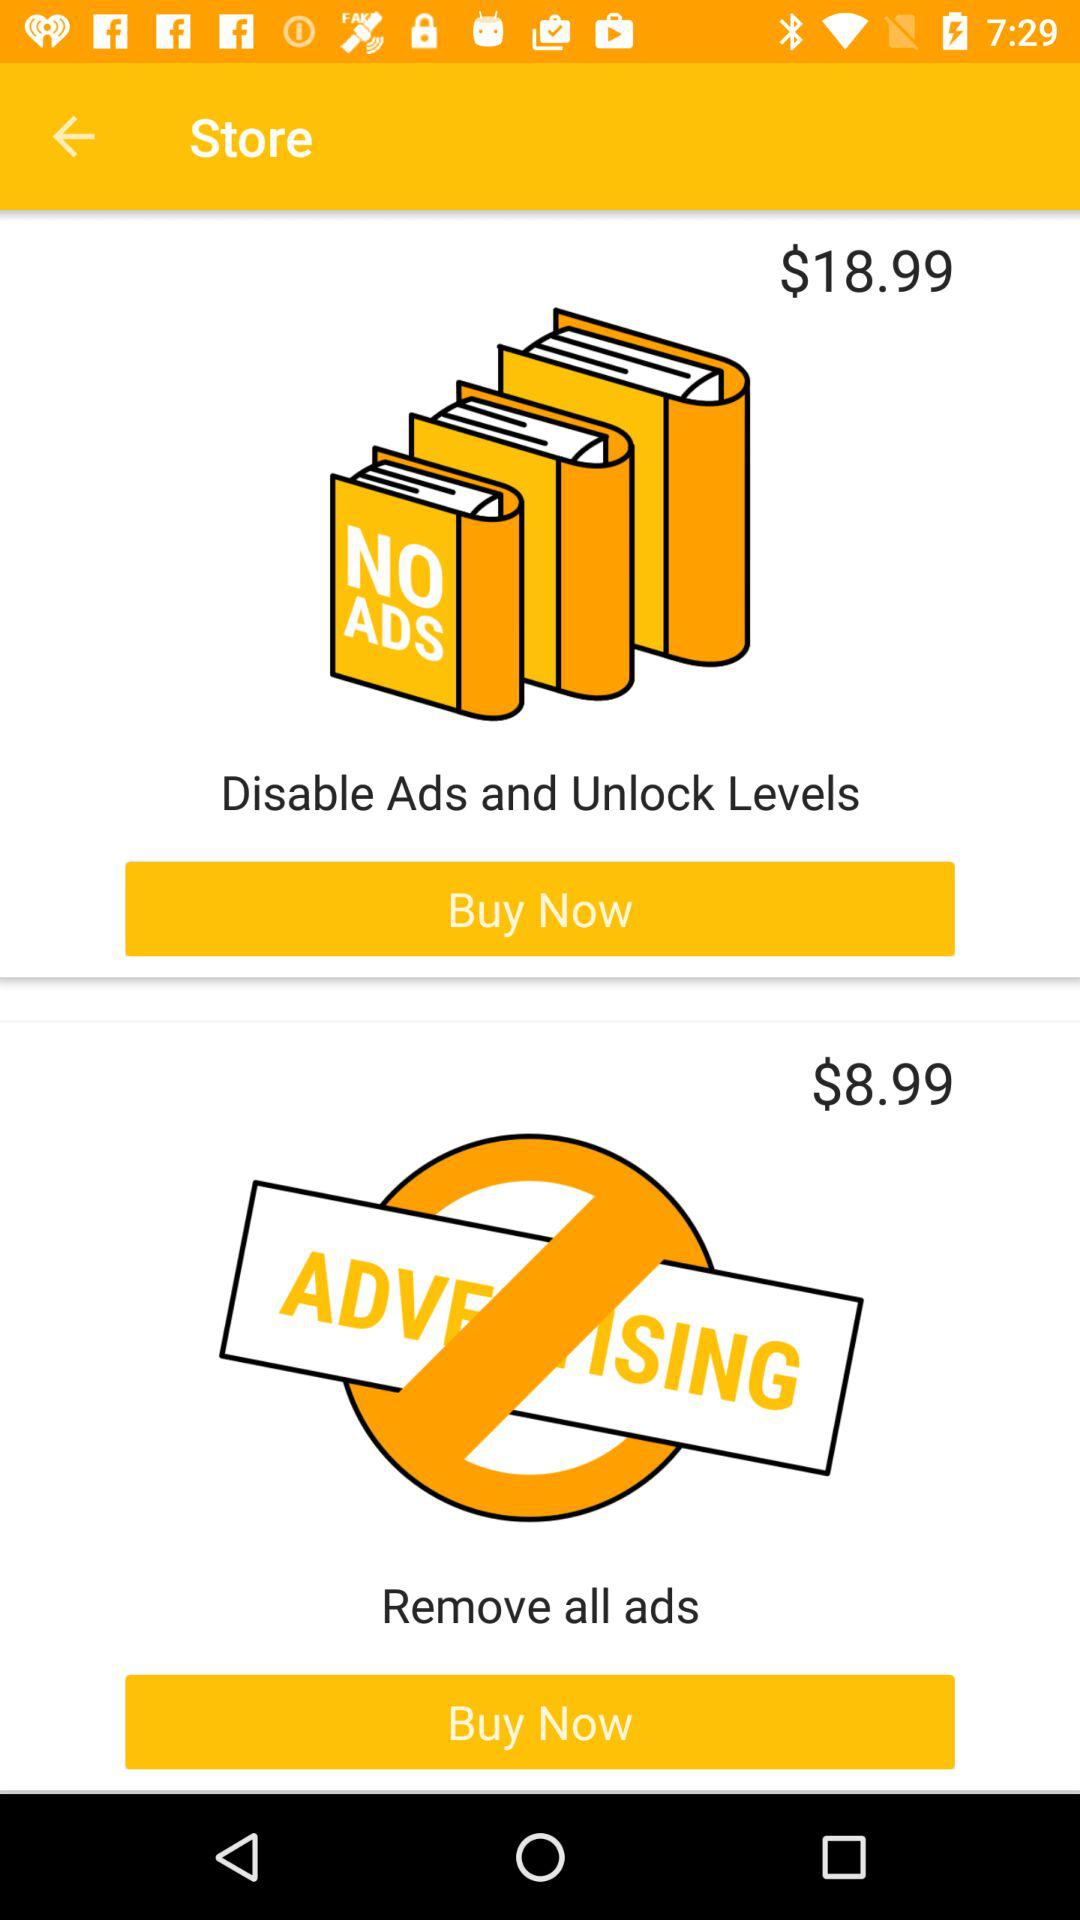How much more does the $18.99 item cost than the $8.99 item?
Answer the question using a single word or phrase. $10.00 